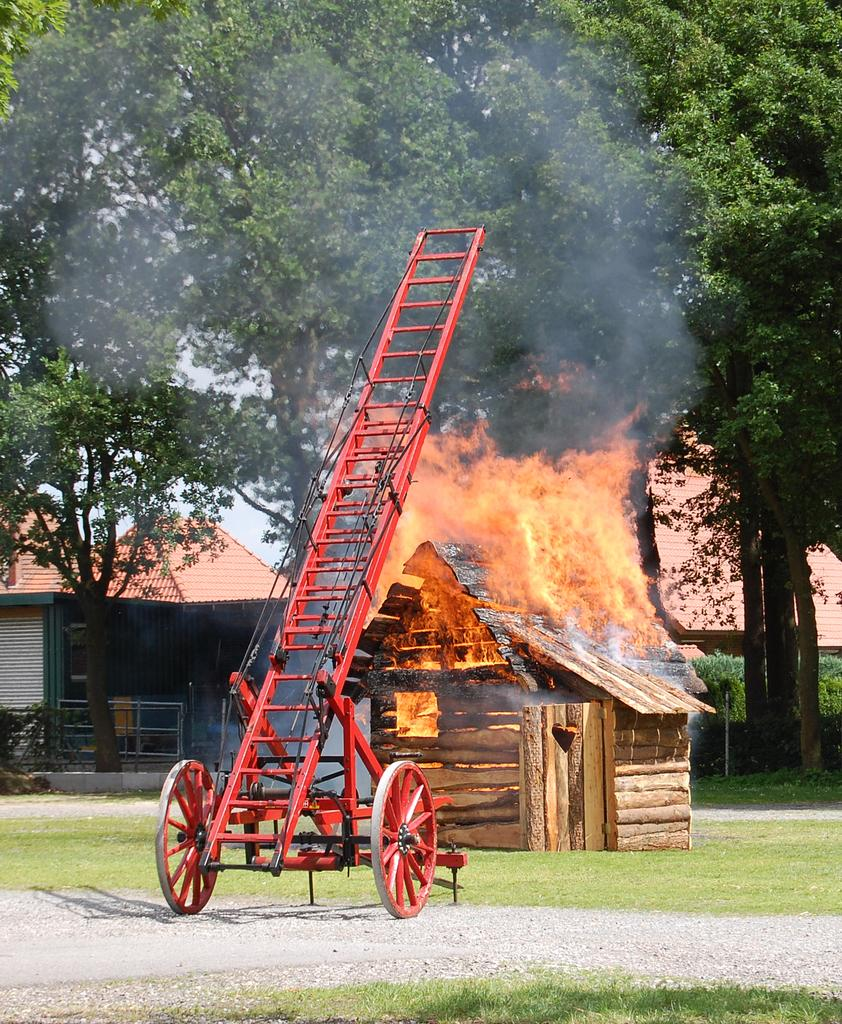What object is present in the image that people might use to reach higher places? There is a ladder in the image. What color is the ladder? The ladder is red. What can be seen in the background of the image? There is a house with fire, a building, trees, and the sky visible in the background. Can you describe the building in the background? The building in the background is white and brown. What color are the trees in the background? The trees in the background are green. What is the color of the sky in the background? The sky is white. What type of oatmeal is being served at the gate in the image? There is no gate or oatmeal present in the image. How many pigs can be seen playing in the background of the image? There are no pigs present in the image. 